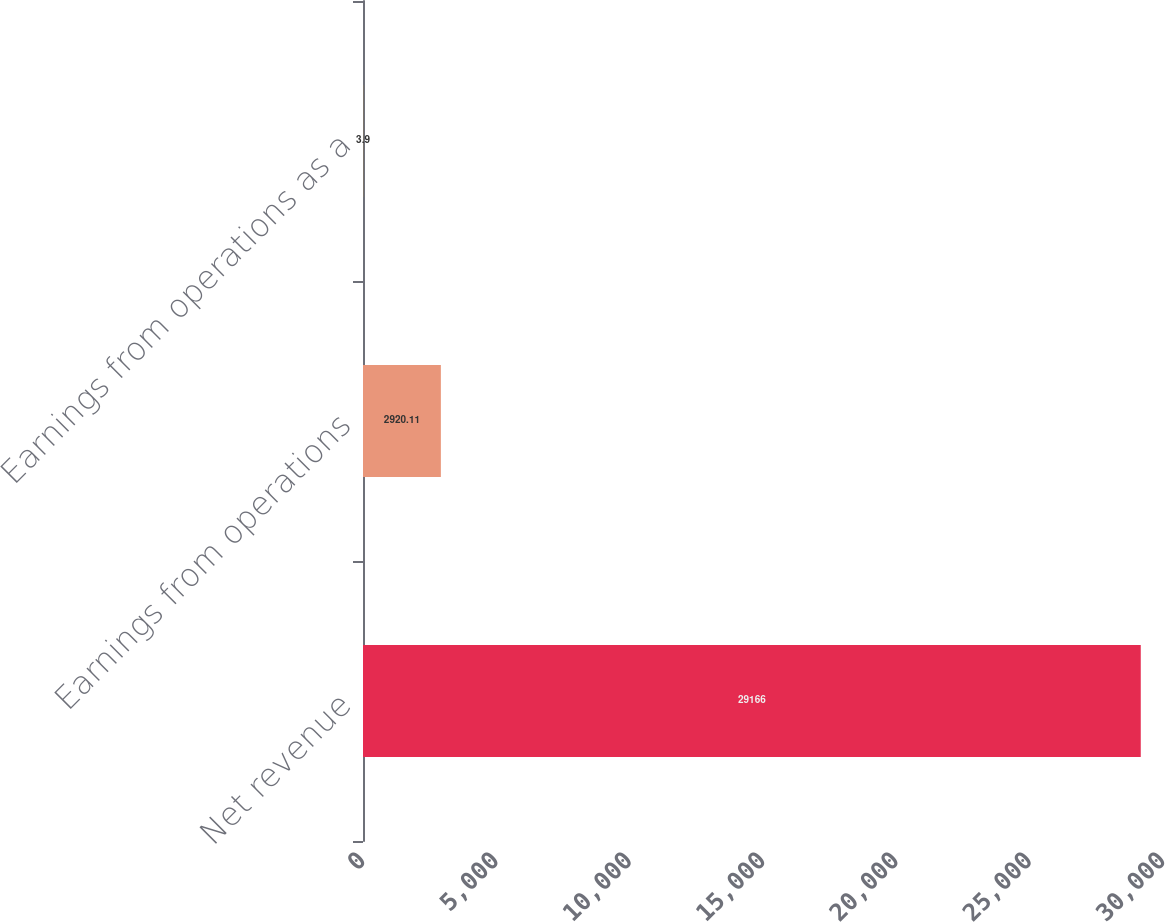Convert chart to OTSL. <chart><loc_0><loc_0><loc_500><loc_500><bar_chart><fcel>Net revenue<fcel>Earnings from operations<fcel>Earnings from operations as a<nl><fcel>29166<fcel>2920.11<fcel>3.9<nl></chart> 